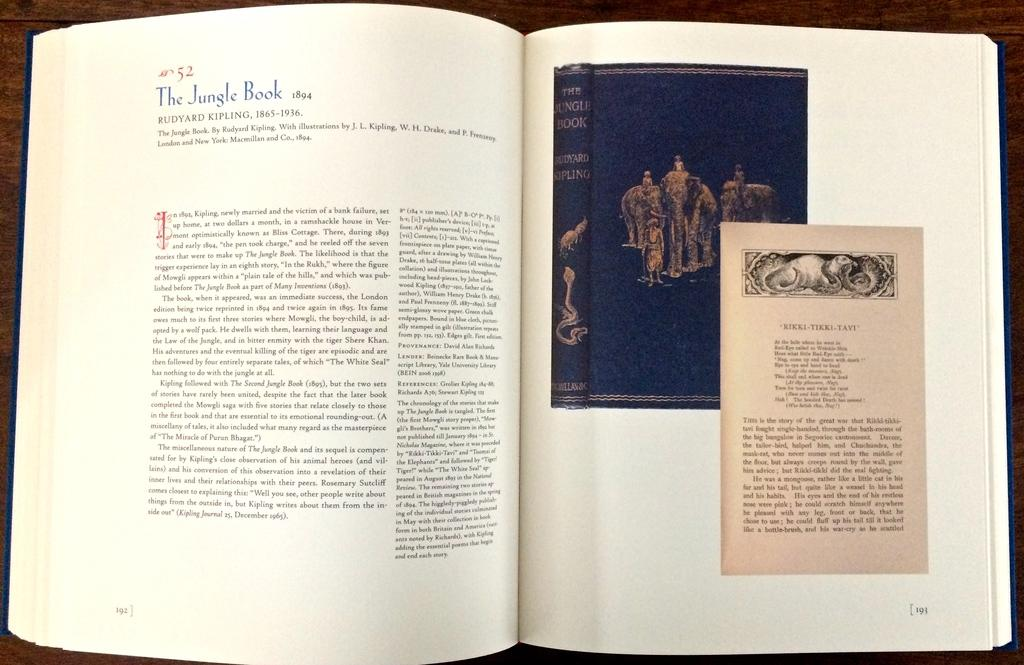Provide a one-sentence caption for the provided image. A reference book shows a picture of an old copy of The Jungle Book. 